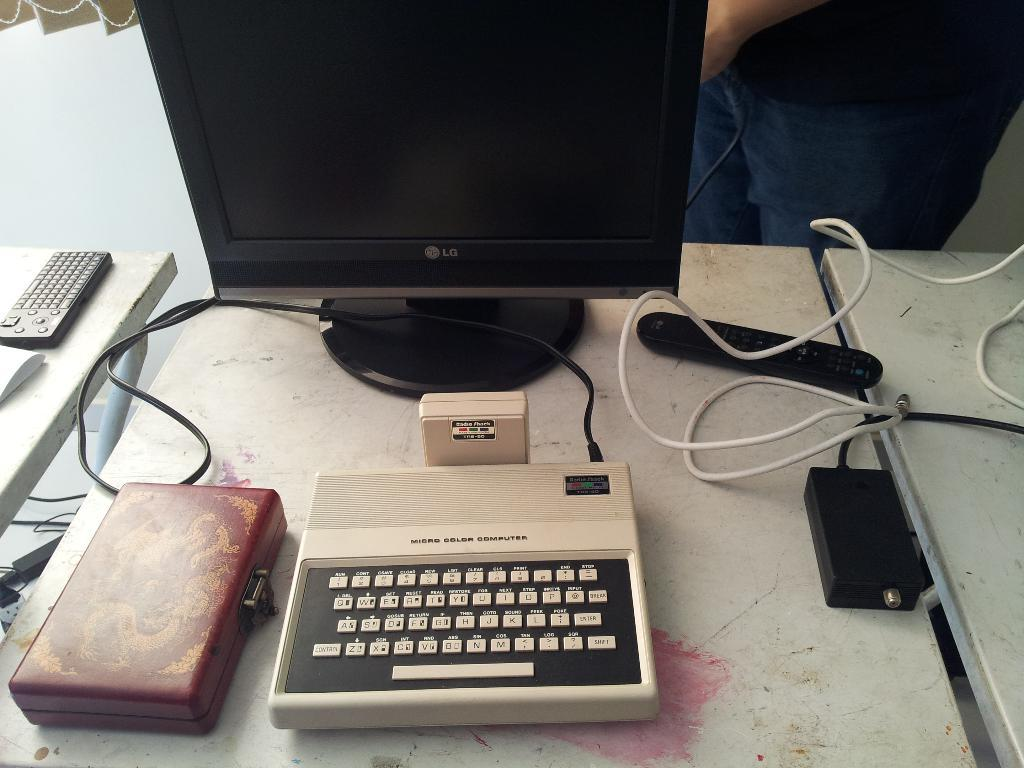<image>
Render a clear and concise summary of the photo. A very old micro color computer is placed in front of a modern LG monitor. 